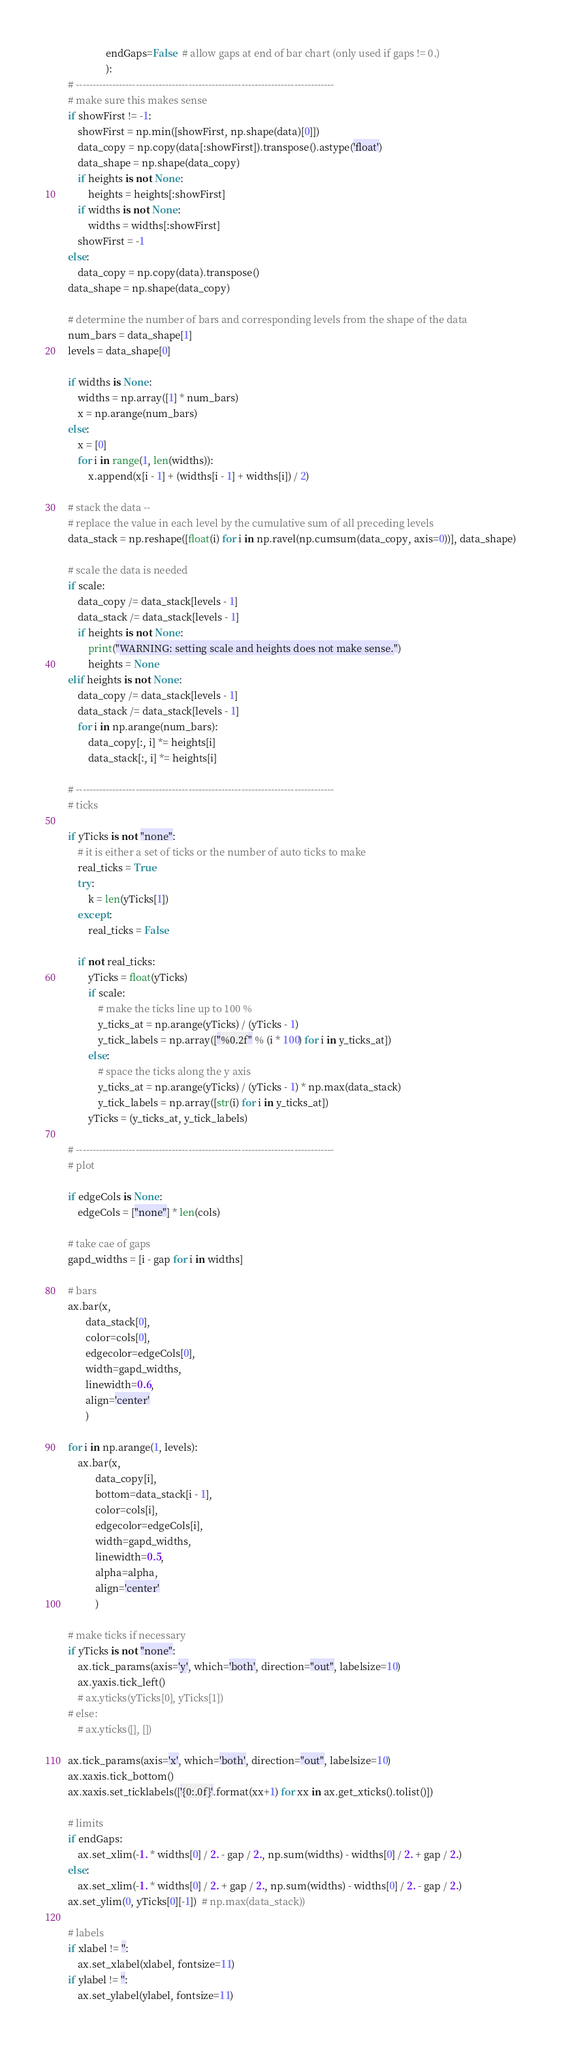Convert code to text. <code><loc_0><loc_0><loc_500><loc_500><_Python_>                   endGaps=False  # allow gaps at end of bar chart (only used if gaps != 0.)
                   ):
    # ------------------------------------------------------------------------------
    # make sure this makes sense
    if showFirst != -1:
        showFirst = np.min([showFirst, np.shape(data)[0]])
        data_copy = np.copy(data[:showFirst]).transpose().astype('float')
        data_shape = np.shape(data_copy)
        if heights is not None:
            heights = heights[:showFirst]
        if widths is not None:
            widths = widths[:showFirst]
        showFirst = -1
    else:
        data_copy = np.copy(data).transpose()
    data_shape = np.shape(data_copy)

    # determine the number of bars and corresponding levels from the shape of the data
    num_bars = data_shape[1]
    levels = data_shape[0]

    if widths is None:
        widths = np.array([1] * num_bars)
        x = np.arange(num_bars)
    else:
        x = [0]
        for i in range(1, len(widths)):
            x.append(x[i - 1] + (widths[i - 1] + widths[i]) / 2)

    # stack the data --
    # replace the value in each level by the cumulative sum of all preceding levels
    data_stack = np.reshape([float(i) for i in np.ravel(np.cumsum(data_copy, axis=0))], data_shape)

    # scale the data is needed
    if scale:
        data_copy /= data_stack[levels - 1]
        data_stack /= data_stack[levels - 1]
        if heights is not None:
            print("WARNING: setting scale and heights does not make sense.")
            heights = None
    elif heights is not None:
        data_copy /= data_stack[levels - 1]
        data_stack /= data_stack[levels - 1]
        for i in np.arange(num_bars):
            data_copy[:, i] *= heights[i]
            data_stack[:, i] *= heights[i]

    # ------------------------------------------------------------------------------
    # ticks

    if yTicks is not "none":
        # it is either a set of ticks or the number of auto ticks to make
        real_ticks = True
        try:
            k = len(yTicks[1])
        except:
            real_ticks = False

        if not real_ticks:
            yTicks = float(yTicks)
            if scale:
                # make the ticks line up to 100 %
                y_ticks_at = np.arange(yTicks) / (yTicks - 1)
                y_tick_labels = np.array(["%0.2f" % (i * 100) for i in y_ticks_at])
            else:
                # space the ticks along the y axis
                y_ticks_at = np.arange(yTicks) / (yTicks - 1) * np.max(data_stack)
                y_tick_labels = np.array([str(i) for i in y_ticks_at])
            yTicks = (y_ticks_at, y_tick_labels)

    # ------------------------------------------------------------------------------
    # plot

    if edgeCols is None:
        edgeCols = ["none"] * len(cols)

    # take cae of gaps
    gapd_widths = [i - gap for i in widths]

    # bars
    ax.bar(x,
           data_stack[0],
           color=cols[0],
           edgecolor=edgeCols[0],
           width=gapd_widths,
           linewidth=0.6,
           align='center'
           )

    for i in np.arange(1, levels):
        ax.bar(x,
               data_copy[i],
               bottom=data_stack[i - 1],
               color=cols[i],
               edgecolor=edgeCols[i],
               width=gapd_widths,
               linewidth=0.5,
               alpha=alpha,
               align='center'
               )

    # make ticks if necessary
    if yTicks is not "none":
        ax.tick_params(axis='y', which='both', direction="out", labelsize=10)
        ax.yaxis.tick_left()
        # ax.yticks(yTicks[0], yTicks[1])
    # else:
        # ax.yticks([], [])

    ax.tick_params(axis='x', which='both', direction="out", labelsize=10)
    ax.xaxis.tick_bottom()
    ax.xaxis.set_ticklabels(['{0:.0f}'.format(xx+1) for xx in ax.get_xticks().tolist()])

    # limits
    if endGaps:
        ax.set_xlim(-1. * widths[0] / 2. - gap / 2., np.sum(widths) - widths[0] / 2. + gap / 2.)
    else:
        ax.set_xlim(-1. * widths[0] / 2. + gap / 2., np.sum(widths) - widths[0] / 2. - gap / 2.)
    ax.set_ylim(0, yTicks[0][-1])  # np.max(data_stack))

    # labels
    if xlabel != '':
        ax.set_xlabel(xlabel, fontsize=11)
    if ylabel != '':
        ax.set_ylabel(ylabel, fontsize=11)
</code> 